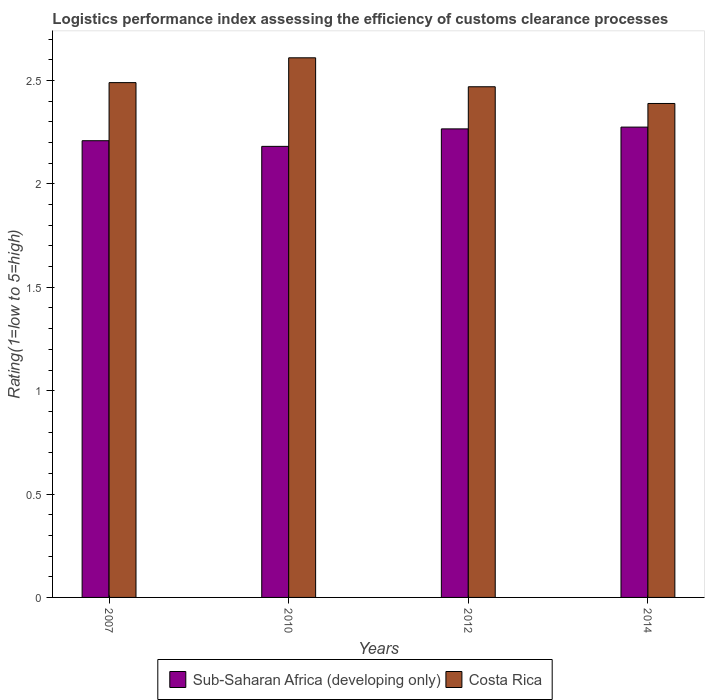How many groups of bars are there?
Give a very brief answer. 4. Are the number of bars per tick equal to the number of legend labels?
Offer a terse response. Yes. Are the number of bars on each tick of the X-axis equal?
Provide a short and direct response. Yes. How many bars are there on the 1st tick from the left?
Provide a short and direct response. 2. How many bars are there on the 3rd tick from the right?
Your response must be concise. 2. What is the label of the 2nd group of bars from the left?
Offer a very short reply. 2010. What is the Logistic performance index in Costa Rica in 2012?
Give a very brief answer. 2.47. Across all years, what is the maximum Logistic performance index in Sub-Saharan Africa (developing only)?
Your answer should be compact. 2.27. Across all years, what is the minimum Logistic performance index in Sub-Saharan Africa (developing only)?
Ensure brevity in your answer.  2.18. In which year was the Logistic performance index in Sub-Saharan Africa (developing only) maximum?
Keep it short and to the point. 2014. In which year was the Logistic performance index in Costa Rica minimum?
Offer a very short reply. 2014. What is the total Logistic performance index in Costa Rica in the graph?
Offer a very short reply. 9.96. What is the difference between the Logistic performance index in Sub-Saharan Africa (developing only) in 2012 and that in 2014?
Offer a terse response. -0.01. What is the difference between the Logistic performance index in Costa Rica in 2010 and the Logistic performance index in Sub-Saharan Africa (developing only) in 2012?
Your answer should be very brief. 0.34. What is the average Logistic performance index in Costa Rica per year?
Your answer should be very brief. 2.49. In the year 2007, what is the difference between the Logistic performance index in Costa Rica and Logistic performance index in Sub-Saharan Africa (developing only)?
Make the answer very short. 0.28. In how many years, is the Logistic performance index in Sub-Saharan Africa (developing only) greater than 1.8?
Your answer should be very brief. 4. What is the ratio of the Logistic performance index in Sub-Saharan Africa (developing only) in 2010 to that in 2012?
Your answer should be very brief. 0.96. Is the difference between the Logistic performance index in Costa Rica in 2007 and 2012 greater than the difference between the Logistic performance index in Sub-Saharan Africa (developing only) in 2007 and 2012?
Keep it short and to the point. Yes. What is the difference between the highest and the second highest Logistic performance index in Costa Rica?
Ensure brevity in your answer.  0.12. What is the difference between the highest and the lowest Logistic performance index in Sub-Saharan Africa (developing only)?
Your answer should be compact. 0.09. Is the sum of the Logistic performance index in Sub-Saharan Africa (developing only) in 2007 and 2012 greater than the maximum Logistic performance index in Costa Rica across all years?
Your response must be concise. Yes. What does the 2nd bar from the left in 2014 represents?
Keep it short and to the point. Costa Rica. How many bars are there?
Keep it short and to the point. 8. Are all the bars in the graph horizontal?
Your response must be concise. No. How many years are there in the graph?
Make the answer very short. 4. What is the difference between two consecutive major ticks on the Y-axis?
Make the answer very short. 0.5. Are the values on the major ticks of Y-axis written in scientific E-notation?
Keep it short and to the point. No. Does the graph contain any zero values?
Keep it short and to the point. No. How many legend labels are there?
Your answer should be very brief. 2. How are the legend labels stacked?
Your answer should be very brief. Horizontal. What is the title of the graph?
Ensure brevity in your answer.  Logistics performance index assessing the efficiency of customs clearance processes. What is the label or title of the Y-axis?
Provide a succinct answer. Rating(1=low to 5=high). What is the Rating(1=low to 5=high) in Sub-Saharan Africa (developing only) in 2007?
Provide a succinct answer. 2.21. What is the Rating(1=low to 5=high) in Costa Rica in 2007?
Your answer should be compact. 2.49. What is the Rating(1=low to 5=high) in Sub-Saharan Africa (developing only) in 2010?
Your answer should be compact. 2.18. What is the Rating(1=low to 5=high) in Costa Rica in 2010?
Provide a short and direct response. 2.61. What is the Rating(1=low to 5=high) in Sub-Saharan Africa (developing only) in 2012?
Make the answer very short. 2.27. What is the Rating(1=low to 5=high) in Costa Rica in 2012?
Provide a short and direct response. 2.47. What is the Rating(1=low to 5=high) in Sub-Saharan Africa (developing only) in 2014?
Provide a short and direct response. 2.27. What is the Rating(1=low to 5=high) in Costa Rica in 2014?
Make the answer very short. 2.39. Across all years, what is the maximum Rating(1=low to 5=high) in Sub-Saharan Africa (developing only)?
Ensure brevity in your answer.  2.27. Across all years, what is the maximum Rating(1=low to 5=high) in Costa Rica?
Provide a short and direct response. 2.61. Across all years, what is the minimum Rating(1=low to 5=high) in Sub-Saharan Africa (developing only)?
Your answer should be compact. 2.18. Across all years, what is the minimum Rating(1=low to 5=high) in Costa Rica?
Make the answer very short. 2.39. What is the total Rating(1=low to 5=high) in Sub-Saharan Africa (developing only) in the graph?
Offer a very short reply. 8.93. What is the total Rating(1=low to 5=high) of Costa Rica in the graph?
Your response must be concise. 9.96. What is the difference between the Rating(1=low to 5=high) of Sub-Saharan Africa (developing only) in 2007 and that in 2010?
Keep it short and to the point. 0.03. What is the difference between the Rating(1=low to 5=high) in Costa Rica in 2007 and that in 2010?
Your answer should be very brief. -0.12. What is the difference between the Rating(1=low to 5=high) in Sub-Saharan Africa (developing only) in 2007 and that in 2012?
Give a very brief answer. -0.06. What is the difference between the Rating(1=low to 5=high) of Costa Rica in 2007 and that in 2012?
Offer a very short reply. 0.02. What is the difference between the Rating(1=low to 5=high) of Sub-Saharan Africa (developing only) in 2007 and that in 2014?
Offer a very short reply. -0.07. What is the difference between the Rating(1=low to 5=high) in Costa Rica in 2007 and that in 2014?
Give a very brief answer. 0.1. What is the difference between the Rating(1=low to 5=high) in Sub-Saharan Africa (developing only) in 2010 and that in 2012?
Keep it short and to the point. -0.08. What is the difference between the Rating(1=low to 5=high) of Costa Rica in 2010 and that in 2012?
Offer a terse response. 0.14. What is the difference between the Rating(1=low to 5=high) in Sub-Saharan Africa (developing only) in 2010 and that in 2014?
Give a very brief answer. -0.09. What is the difference between the Rating(1=low to 5=high) in Costa Rica in 2010 and that in 2014?
Keep it short and to the point. 0.22. What is the difference between the Rating(1=low to 5=high) in Sub-Saharan Africa (developing only) in 2012 and that in 2014?
Make the answer very short. -0.01. What is the difference between the Rating(1=low to 5=high) in Costa Rica in 2012 and that in 2014?
Make the answer very short. 0.08. What is the difference between the Rating(1=low to 5=high) of Sub-Saharan Africa (developing only) in 2007 and the Rating(1=low to 5=high) of Costa Rica in 2010?
Provide a succinct answer. -0.4. What is the difference between the Rating(1=low to 5=high) of Sub-Saharan Africa (developing only) in 2007 and the Rating(1=low to 5=high) of Costa Rica in 2012?
Provide a succinct answer. -0.26. What is the difference between the Rating(1=low to 5=high) in Sub-Saharan Africa (developing only) in 2007 and the Rating(1=low to 5=high) in Costa Rica in 2014?
Your answer should be compact. -0.18. What is the difference between the Rating(1=low to 5=high) of Sub-Saharan Africa (developing only) in 2010 and the Rating(1=low to 5=high) of Costa Rica in 2012?
Provide a short and direct response. -0.29. What is the difference between the Rating(1=low to 5=high) of Sub-Saharan Africa (developing only) in 2010 and the Rating(1=low to 5=high) of Costa Rica in 2014?
Your answer should be very brief. -0.21. What is the difference between the Rating(1=low to 5=high) of Sub-Saharan Africa (developing only) in 2012 and the Rating(1=low to 5=high) of Costa Rica in 2014?
Offer a terse response. -0.12. What is the average Rating(1=low to 5=high) in Sub-Saharan Africa (developing only) per year?
Provide a short and direct response. 2.23. What is the average Rating(1=low to 5=high) in Costa Rica per year?
Keep it short and to the point. 2.49. In the year 2007, what is the difference between the Rating(1=low to 5=high) in Sub-Saharan Africa (developing only) and Rating(1=low to 5=high) in Costa Rica?
Offer a very short reply. -0.28. In the year 2010, what is the difference between the Rating(1=low to 5=high) of Sub-Saharan Africa (developing only) and Rating(1=low to 5=high) of Costa Rica?
Offer a very short reply. -0.43. In the year 2012, what is the difference between the Rating(1=low to 5=high) in Sub-Saharan Africa (developing only) and Rating(1=low to 5=high) in Costa Rica?
Your response must be concise. -0.2. In the year 2014, what is the difference between the Rating(1=low to 5=high) in Sub-Saharan Africa (developing only) and Rating(1=low to 5=high) in Costa Rica?
Provide a succinct answer. -0.11. What is the ratio of the Rating(1=low to 5=high) in Sub-Saharan Africa (developing only) in 2007 to that in 2010?
Ensure brevity in your answer.  1.01. What is the ratio of the Rating(1=low to 5=high) of Costa Rica in 2007 to that in 2010?
Offer a terse response. 0.95. What is the ratio of the Rating(1=low to 5=high) in Sub-Saharan Africa (developing only) in 2007 to that in 2012?
Provide a succinct answer. 0.97. What is the ratio of the Rating(1=low to 5=high) of Costa Rica in 2007 to that in 2012?
Your response must be concise. 1.01. What is the ratio of the Rating(1=low to 5=high) of Sub-Saharan Africa (developing only) in 2007 to that in 2014?
Your response must be concise. 0.97. What is the ratio of the Rating(1=low to 5=high) in Costa Rica in 2007 to that in 2014?
Ensure brevity in your answer.  1.04. What is the ratio of the Rating(1=low to 5=high) in Sub-Saharan Africa (developing only) in 2010 to that in 2012?
Give a very brief answer. 0.96. What is the ratio of the Rating(1=low to 5=high) in Costa Rica in 2010 to that in 2012?
Your response must be concise. 1.06. What is the ratio of the Rating(1=low to 5=high) in Costa Rica in 2010 to that in 2014?
Provide a succinct answer. 1.09. What is the ratio of the Rating(1=low to 5=high) of Sub-Saharan Africa (developing only) in 2012 to that in 2014?
Give a very brief answer. 1. What is the ratio of the Rating(1=low to 5=high) in Costa Rica in 2012 to that in 2014?
Offer a very short reply. 1.03. What is the difference between the highest and the second highest Rating(1=low to 5=high) of Sub-Saharan Africa (developing only)?
Give a very brief answer. 0.01. What is the difference between the highest and the second highest Rating(1=low to 5=high) in Costa Rica?
Provide a short and direct response. 0.12. What is the difference between the highest and the lowest Rating(1=low to 5=high) of Sub-Saharan Africa (developing only)?
Provide a succinct answer. 0.09. What is the difference between the highest and the lowest Rating(1=low to 5=high) in Costa Rica?
Offer a terse response. 0.22. 